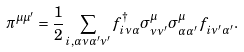Convert formula to latex. <formula><loc_0><loc_0><loc_500><loc_500>\pi ^ { \mu \mu ^ { \prime } } = \frac { 1 } { 2 } \sum _ { { i } , \alpha \nu \alpha ^ { \prime } \nu ^ { \prime } } f ^ { \dagger } _ { { i } \nu \alpha } { \sigma } ^ { \mu } _ { \nu \nu ^ { \prime } } { \sigma } ^ { \mu } _ { \alpha \alpha ^ { \prime } } f ^ { \, } _ { { i } \nu ^ { \prime } \alpha ^ { \prime } } .</formula> 